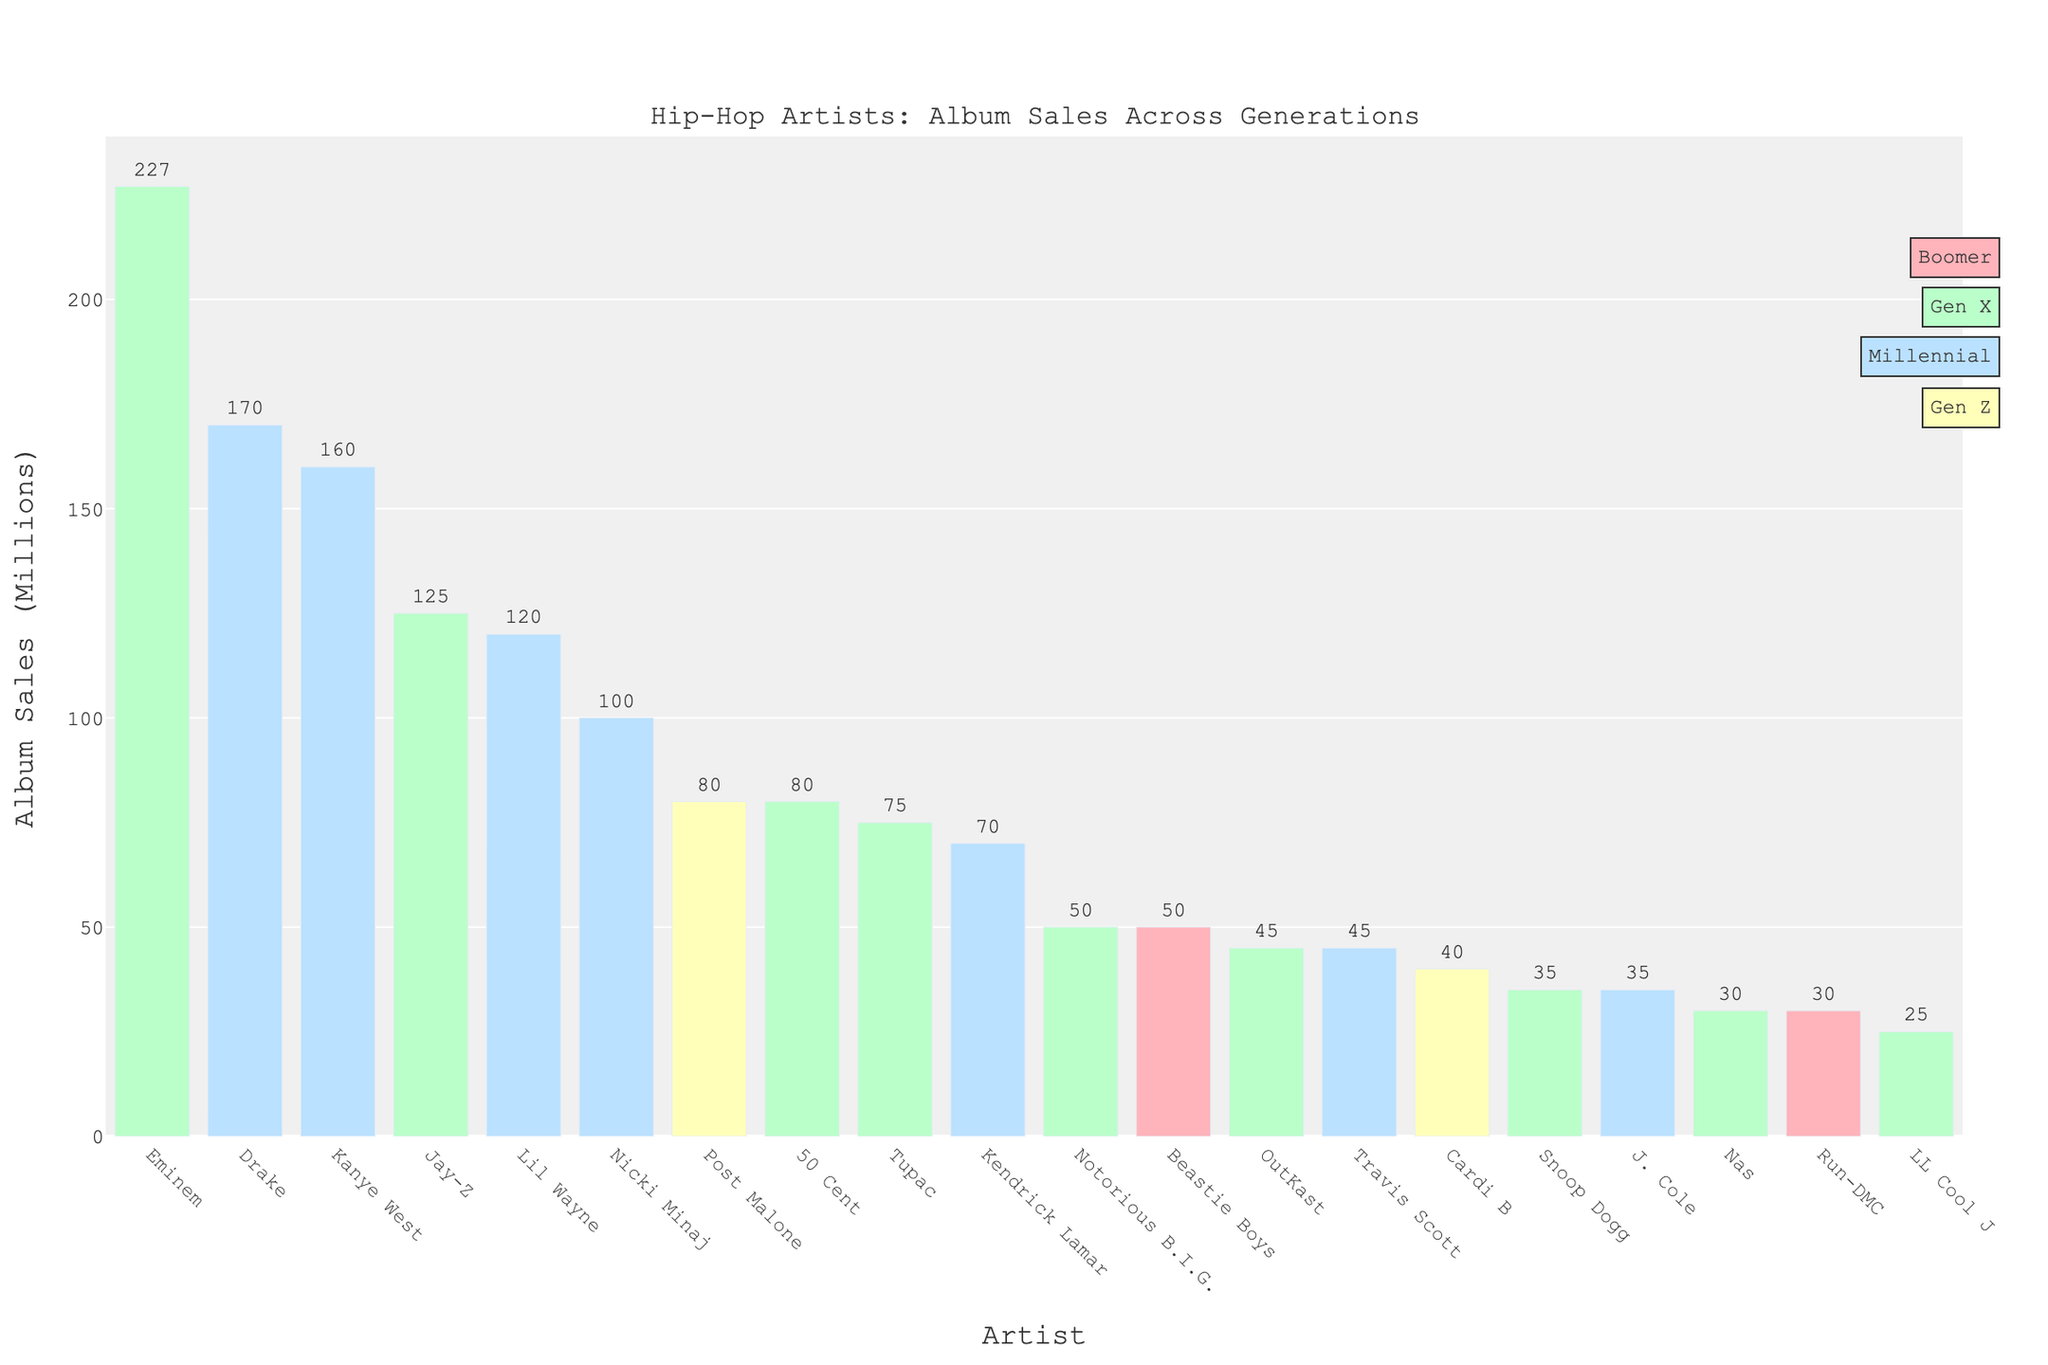Which artist has the highest album sales? Eminem has the highest album sales. By looking at the figure, considering the bar heights and labels, Eminem's bar is the tallest at 227 million albums.
Answer: Eminem How do the album sales of Drake compare to those of Kanye West? Drake's and Kanye West's album sales are close, but Drake's is slightly higher. Drake has 170 million album sales, and Kanye West has 160 million. Compare the bar heights and labeled values.
Answer: Drake has 10 million more album sales than Kanye West What is the total album sales for all Gen Z artists? Add the album sales of the two Gen Z artists, Cardi B and Post Malone: 40 million + 80 million.
Answer: 120 million Which generation has more artists listed in the top album sales, Gen X or Millennial? Count the number of artists and compare. Gen X: Eminem, Jay-Z, Tupac, Notorious B.I.G., OutKast, 50 Cent, Nas, Snoop Dogg, LL Cool J (9 artists). Millennial: Drake, Kanye West, Lil Wayne, Nicki Minaj, Kendrick Lamar, Travis Scott, J. Cole (7 artists).
Answer: Gen X Who's the top-selling Boomer artist, and how many albums did they sell? Among the Boomers, Beastie Boys and Run-DMC are listed. By comparing their bar heights and labels, Beastie Boys and Run-DMC both have bars of equal height, indicating they both sold 50 million albums.
Answer: Beastie Boys and Run-DMC, 50 million each What is the difference in album sales between the highest-selling artist and the lowest-selling artist? Compare Eminem's highest sales (227 million) with LL Cool J's lowest sales (25 million). Calculate the difference: 227 million - 25 million.
Answer: 202 million Which artist has the lowest album sales among Millennials? Compare the bar heights and labels of Millennial artists: J. Cole has the lowest sales at 35 million.
Answer: J. Cole What’s the average album sales of Gen X artists? Sum the album sales of Gen X artists: 227 + 125 + 75 + 50 + 45 + 80 + 30 + 35 + 25 = 692 million. Divide by the number of Gen X artists (9): 692 million / 9.
Answer: Approximately 76.9 million Who are the top three artists with the closest album sales to 100 million? Compare the sales figures and identify the three artists closest to 100 million. Lil Wayne (120 million), Nicki Minaj (100 million), and 50 Cent (80 million) are closest, out of the possible figures.
Answer: Nicki Minaj, 50 Cent, and Lil Wayne 